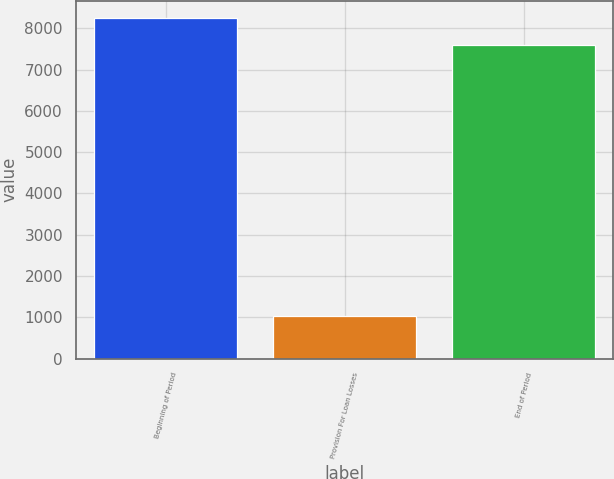<chart> <loc_0><loc_0><loc_500><loc_500><bar_chart><fcel>Beginning of Period<fcel>Provision For Loan Losses<fcel>End of Period<nl><fcel>8253.5<fcel>1037<fcel>7593<nl></chart> 